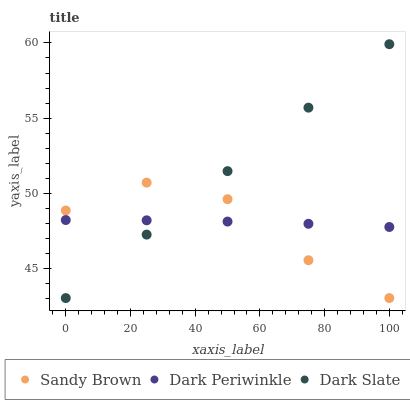Does Sandy Brown have the minimum area under the curve?
Answer yes or no. Yes. Does Dark Slate have the maximum area under the curve?
Answer yes or no. Yes. Does Dark Periwinkle have the minimum area under the curve?
Answer yes or no. No. Does Dark Periwinkle have the maximum area under the curve?
Answer yes or no. No. Is Dark Slate the smoothest?
Answer yes or no. Yes. Is Sandy Brown the roughest?
Answer yes or no. Yes. Is Dark Periwinkle the smoothest?
Answer yes or no. No. Is Dark Periwinkle the roughest?
Answer yes or no. No. Does Dark Slate have the lowest value?
Answer yes or no. Yes. Does Dark Periwinkle have the lowest value?
Answer yes or no. No. Does Dark Slate have the highest value?
Answer yes or no. Yes. Does Sandy Brown have the highest value?
Answer yes or no. No. Does Dark Periwinkle intersect Dark Slate?
Answer yes or no. Yes. Is Dark Periwinkle less than Dark Slate?
Answer yes or no. No. Is Dark Periwinkle greater than Dark Slate?
Answer yes or no. No. 